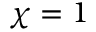<formula> <loc_0><loc_0><loc_500><loc_500>\chi = 1</formula> 